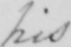Please transcribe the handwritten text in this image. his 